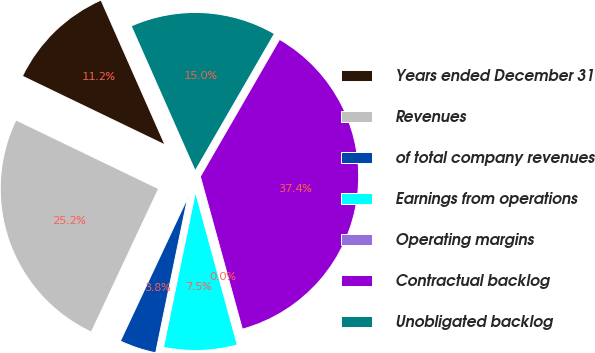Convert chart. <chart><loc_0><loc_0><loc_500><loc_500><pie_chart><fcel>Years ended December 31<fcel>Revenues<fcel>of total company revenues<fcel>Earnings from operations<fcel>Operating margins<fcel>Contractual backlog<fcel>Unobligated backlog<nl><fcel>11.23%<fcel>25.16%<fcel>3.75%<fcel>7.49%<fcel>0.02%<fcel>37.38%<fcel>14.96%<nl></chart> 